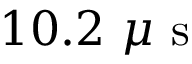Convert formula to latex. <formula><loc_0><loc_0><loc_500><loc_500>1 0 . 2 \mu s</formula> 